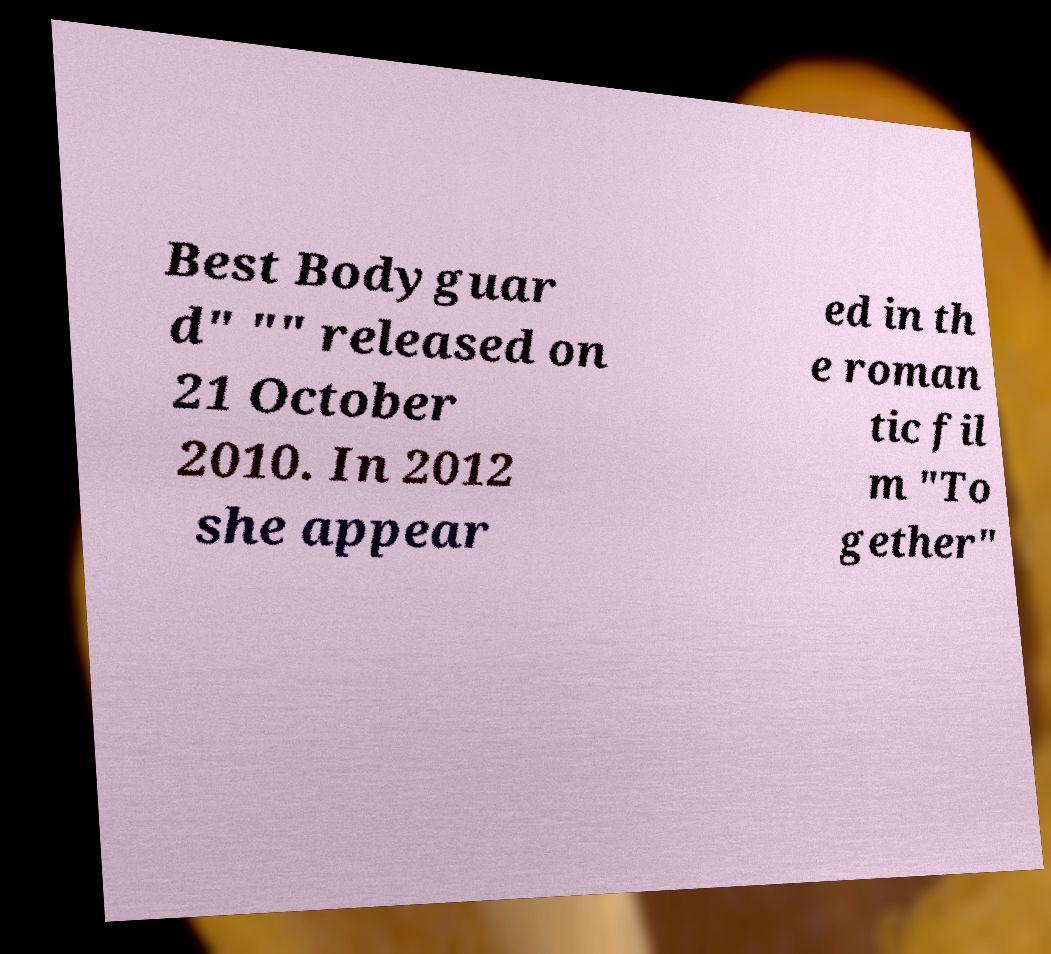There's text embedded in this image that I need extracted. Can you transcribe it verbatim? Best Bodyguar d" "" released on 21 October 2010. In 2012 she appear ed in th e roman tic fil m "To gether" 